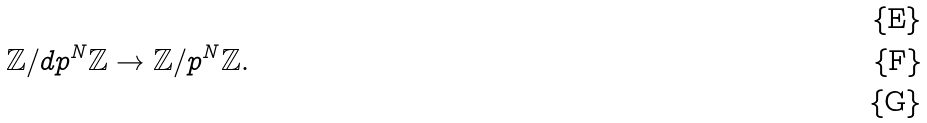<formula> <loc_0><loc_0><loc_500><loc_500>& \\ & \mathbb { Z } / d p ^ { N } \mathbb { Z } \rightarrow \mathbb { Z } / p ^ { N } \mathbb { Z } . \\ &</formula> 